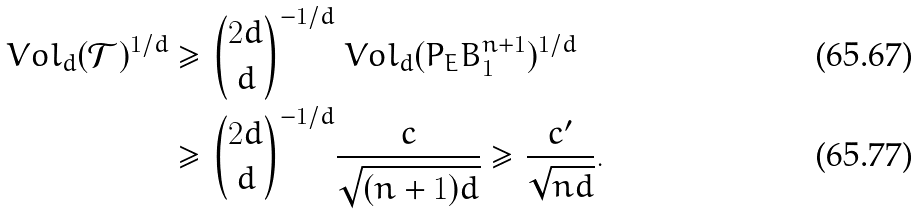<formula> <loc_0><loc_0><loc_500><loc_500>\ V o l _ { d } ( \mathcal { T } ) ^ { 1 / d } & \geq { 2 d \choose d } ^ { - 1 / d } \ V o l _ { d } ( P _ { E } B _ { 1 } ^ { n + 1 } ) ^ { 1 / d } \\ & \geq { 2 d \choose d } ^ { - 1 / d } \frac { c } { \sqrt { ( n + 1 ) d } } \geq \frac { c ^ { \prime } } { \sqrt { n d } } .</formula> 